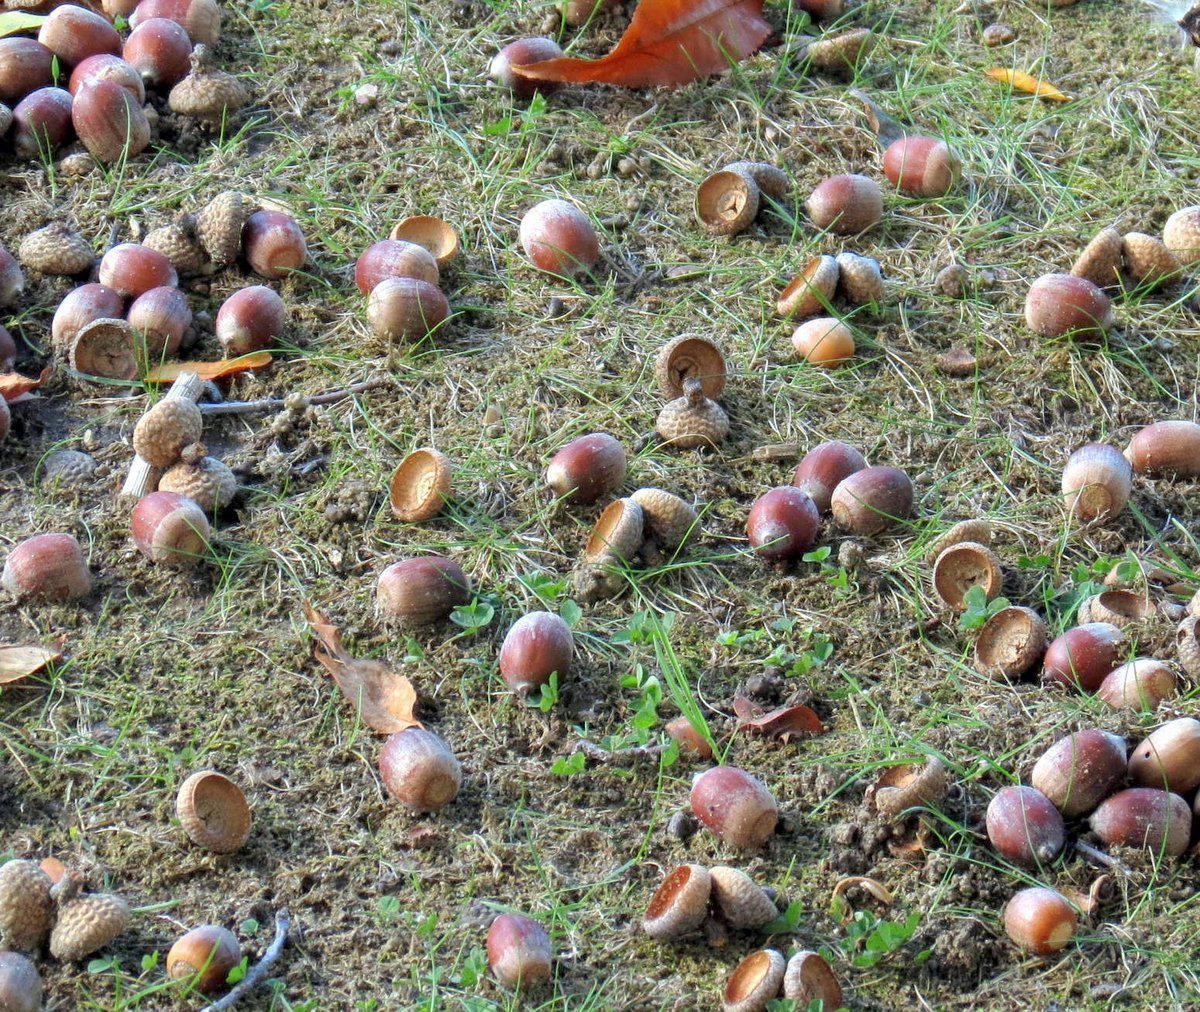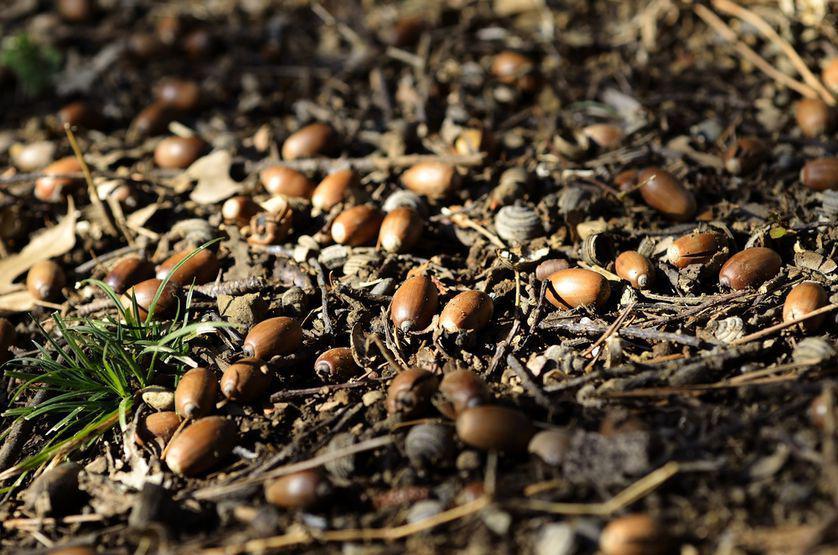The first image is the image on the left, the second image is the image on the right. Considering the images on both sides, is "There are at least 30 acorn bottoms sitting in the dirt with very little grass." valid? Answer yes or no. Yes. The first image is the image on the left, the second image is the image on the right. For the images displayed, is the sentence "There are acorns laying in the dirt." factually correct? Answer yes or no. Yes. 